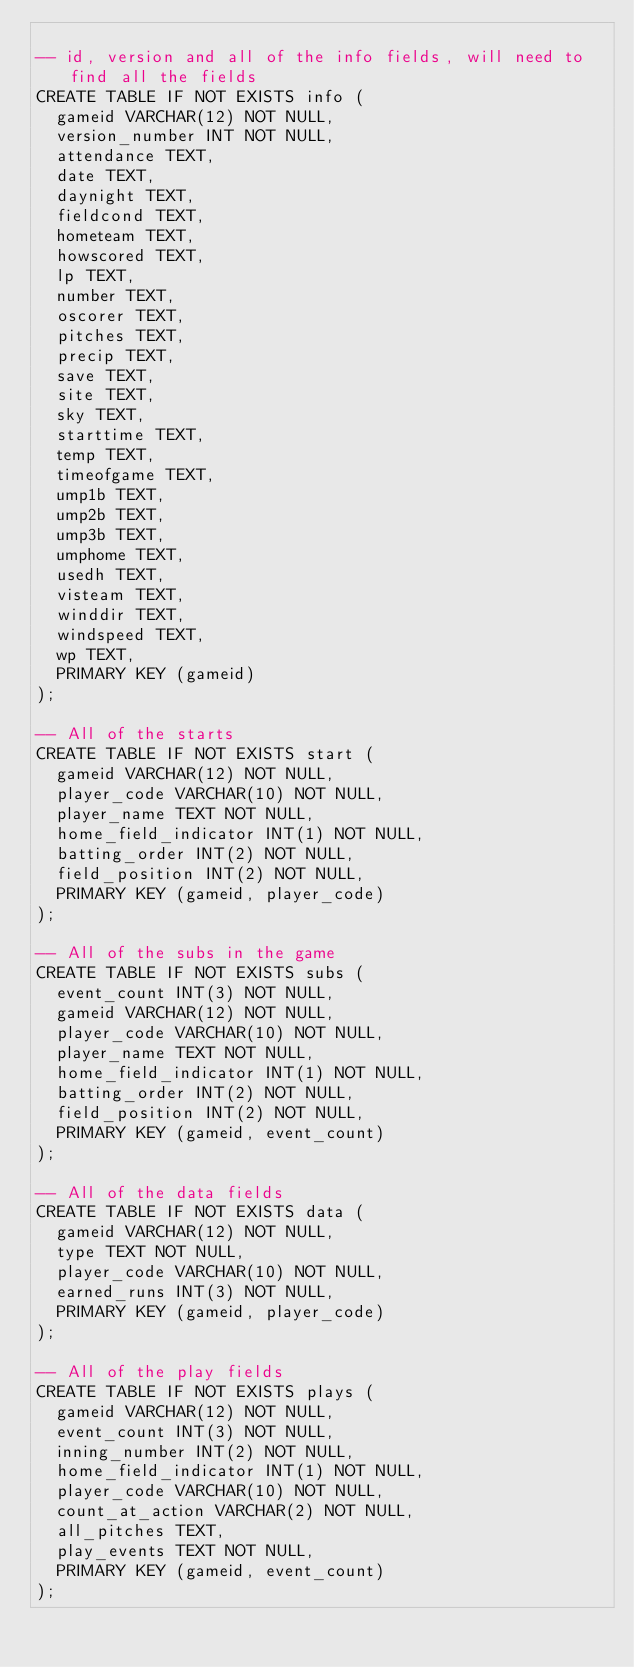<code> <loc_0><loc_0><loc_500><loc_500><_SQL_>
-- id, version and all of the info fields, will need to find all the fields
CREATE TABLE IF NOT EXISTS info (
  gameid VARCHAR(12) NOT NULL,
  version_number INT NOT NULL,
  attendance TEXT,
  date TEXT,
  daynight TEXT,
  fieldcond TEXT,
  hometeam TEXT,
  howscored TEXT,
  lp TEXT,
  number TEXT,
  oscorer TEXT,
  pitches TEXT,
  precip TEXT,
  save TEXT,
  site TEXT,
  sky TEXT,
  starttime TEXT,
  temp TEXT,
  timeofgame TEXT,
  ump1b TEXT,
  ump2b TEXT,
  ump3b TEXT,
  umphome TEXT,
  usedh TEXT,
  visteam TEXT,
  winddir TEXT,
  windspeed TEXT,
  wp TEXT,
  PRIMARY KEY (gameid)
);

-- All of the starts
CREATE TABLE IF NOT EXISTS start (
  gameid VARCHAR(12) NOT NULL,
  player_code VARCHAR(10) NOT NULL,
  player_name TEXT NOT NULL,
  home_field_indicator INT(1) NOT NULL,
  batting_order INT(2) NOT NULL,
  field_position INT(2) NOT NULL,
  PRIMARY KEY (gameid, player_code)
);

-- All of the subs in the game
CREATE TABLE IF NOT EXISTS subs (
  event_count INT(3) NOT NULL,
  gameid VARCHAR(12) NOT NULL,
  player_code VARCHAR(10) NOT NULL,
  player_name TEXT NOT NULL,
  home_field_indicator INT(1) NOT NULL,
  batting_order INT(2) NOT NULL,
  field_position INT(2) NOT NULL,
  PRIMARY KEY (gameid, event_count)
);

-- All of the data fields
CREATE TABLE IF NOT EXISTS data (
  gameid VARCHAR(12) NOT NULL,
  type TEXT NOT NULL,
  player_code VARCHAR(10) NOT NULL,
  earned_runs INT(3) NOT NULL,
  PRIMARY KEY (gameid, player_code)
);

-- All of the play fields
CREATE TABLE IF NOT EXISTS plays (
  gameid VARCHAR(12) NOT NULL,
  event_count INT(3) NOT NULL,
  inning_number INT(2) NOT NULL,
  home_field_indicator INT(1) NOT NULL,
  player_code VARCHAR(10) NOT NULL,
  count_at_action VARCHAR(2) NOT NULL,
  all_pitches TEXT,
  play_events TEXT NOT NULL,
  PRIMARY KEY (gameid, event_count)
);
</code> 